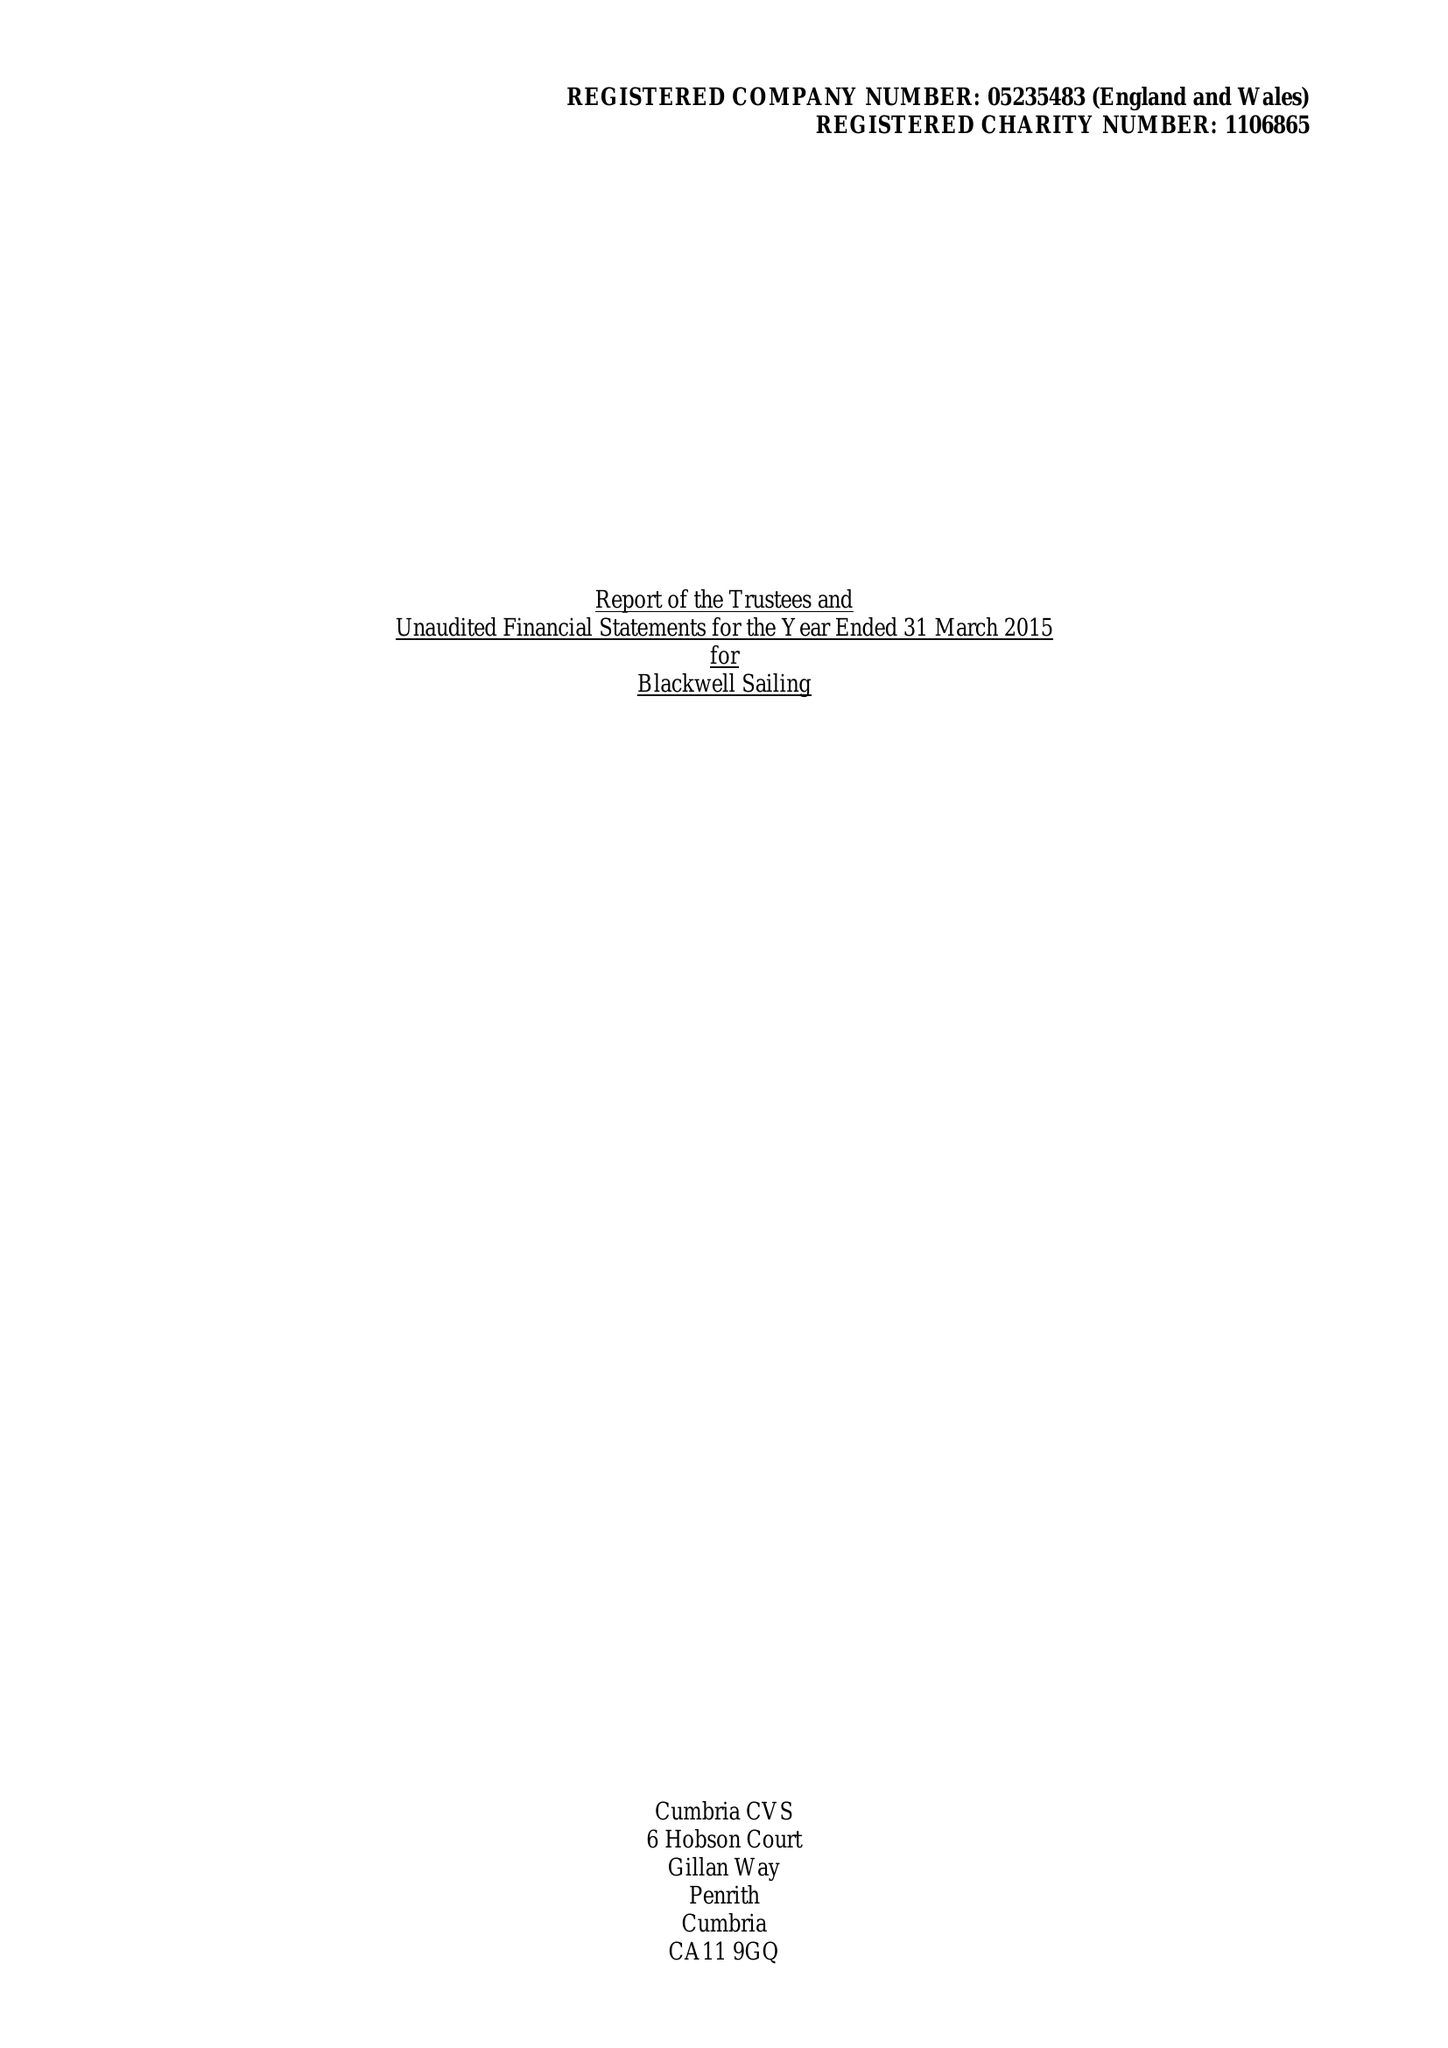What is the value for the address__postcode?
Answer the question using a single word or phrase. LA23 3HE 